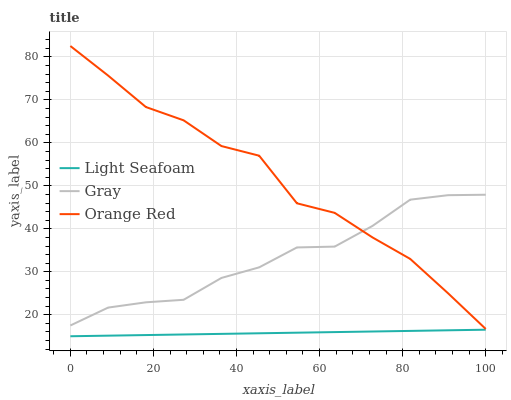Does Light Seafoam have the minimum area under the curve?
Answer yes or no. Yes. Does Orange Red have the maximum area under the curve?
Answer yes or no. Yes. Does Orange Red have the minimum area under the curve?
Answer yes or no. No. Does Light Seafoam have the maximum area under the curve?
Answer yes or no. No. Is Light Seafoam the smoothest?
Answer yes or no. Yes. Is Orange Red the roughest?
Answer yes or no. Yes. Is Orange Red the smoothest?
Answer yes or no. No. Is Light Seafoam the roughest?
Answer yes or no. No. Does Light Seafoam have the lowest value?
Answer yes or no. Yes. Does Orange Red have the lowest value?
Answer yes or no. No. Does Orange Red have the highest value?
Answer yes or no. Yes. Does Light Seafoam have the highest value?
Answer yes or no. No. Is Light Seafoam less than Orange Red?
Answer yes or no. Yes. Is Gray greater than Light Seafoam?
Answer yes or no. Yes. Does Gray intersect Orange Red?
Answer yes or no. Yes. Is Gray less than Orange Red?
Answer yes or no. No. Is Gray greater than Orange Red?
Answer yes or no. No. Does Light Seafoam intersect Orange Red?
Answer yes or no. No. 